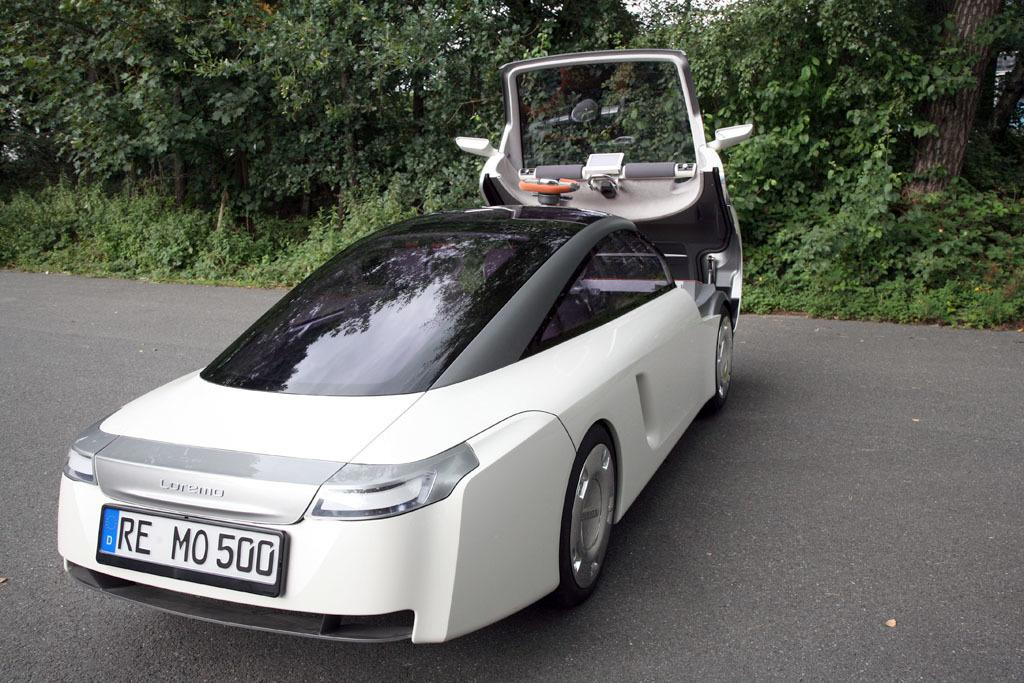What color is the vehicle in the image? The vehicle in the image is white. Where is the vehicle located? The vehicle is on the road. What can be seen in the background of the image? There are trees and the sky visible in the background. What is the color of the trees in the image? The trees are green. What is the color of the sky in the image? The sky is white. What time does the carpenter arrive in the image? There is no carpenter present in the image, so it is not possible to determine when they might arrive. 